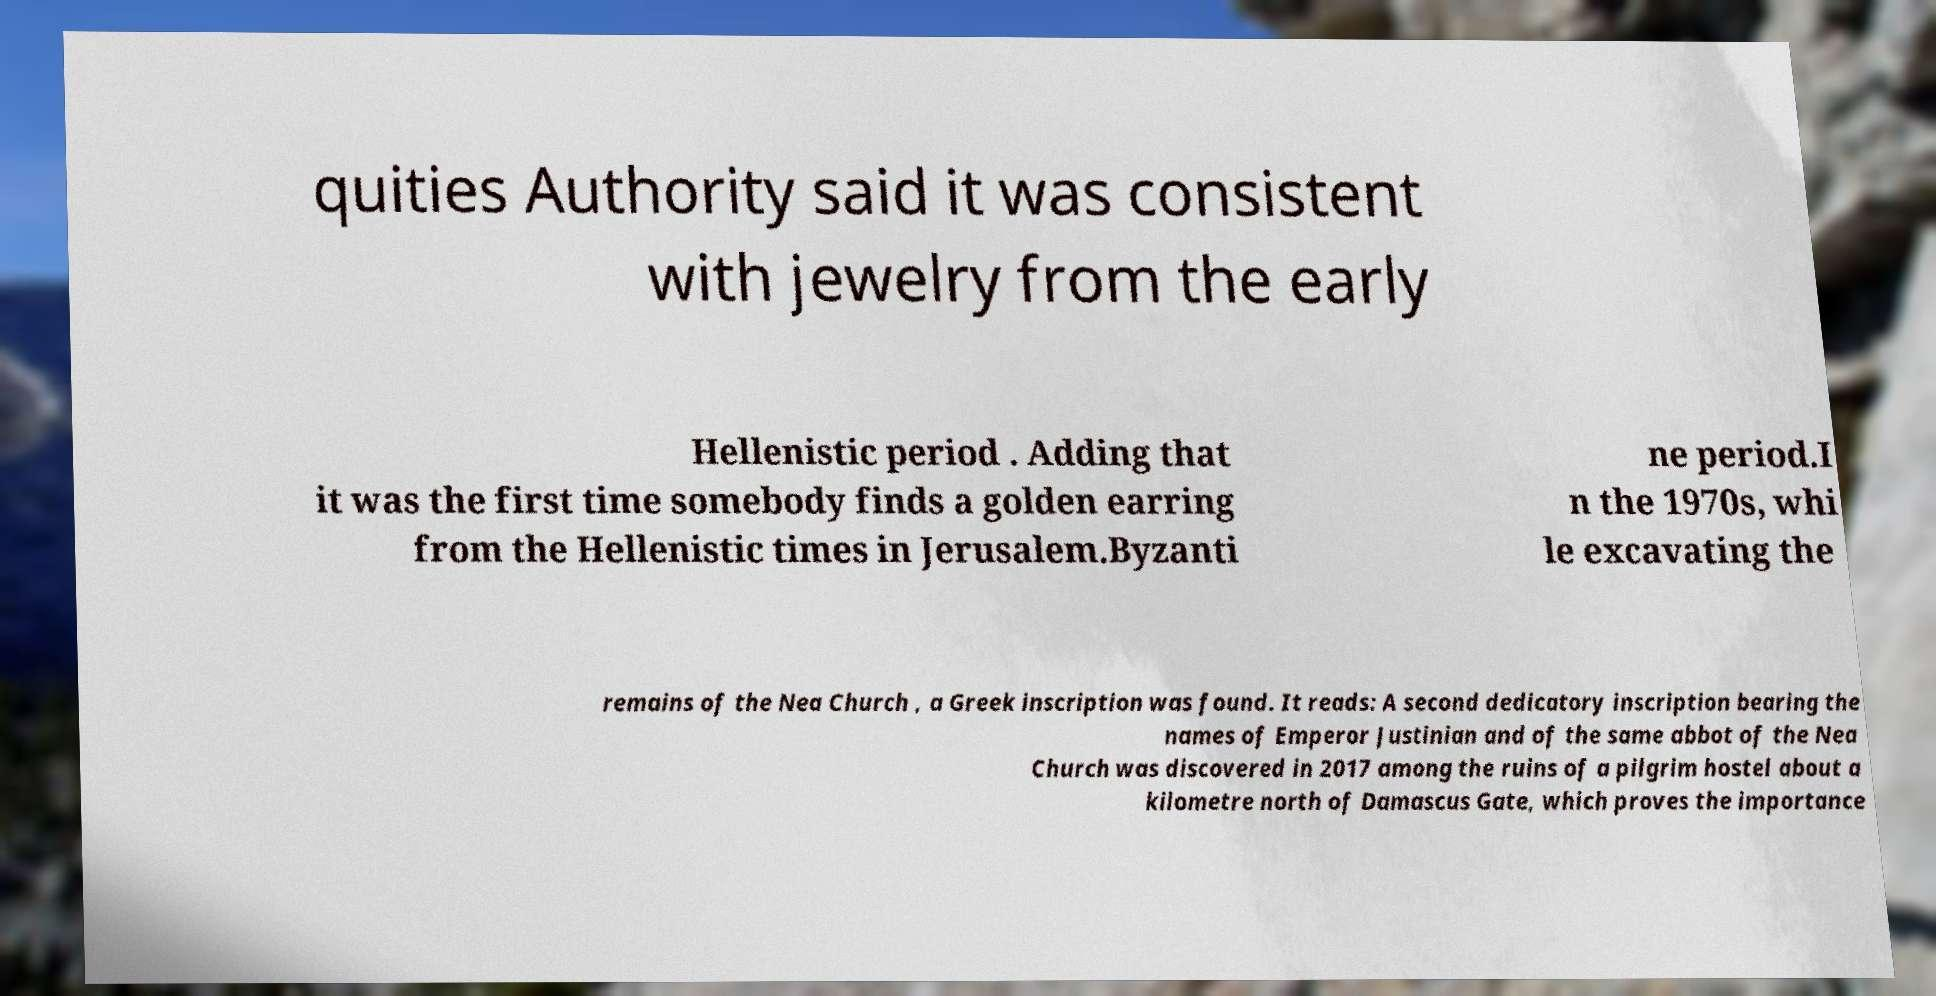For documentation purposes, I need the text within this image transcribed. Could you provide that? quities Authority said it was consistent with jewelry from the early Hellenistic period . Adding that it was the first time somebody finds a golden earring from the Hellenistic times in Jerusalem.Byzanti ne period.I n the 1970s, whi le excavating the remains of the Nea Church , a Greek inscription was found. It reads: A second dedicatory inscription bearing the names of Emperor Justinian and of the same abbot of the Nea Church was discovered in 2017 among the ruins of a pilgrim hostel about a kilometre north of Damascus Gate, which proves the importance 